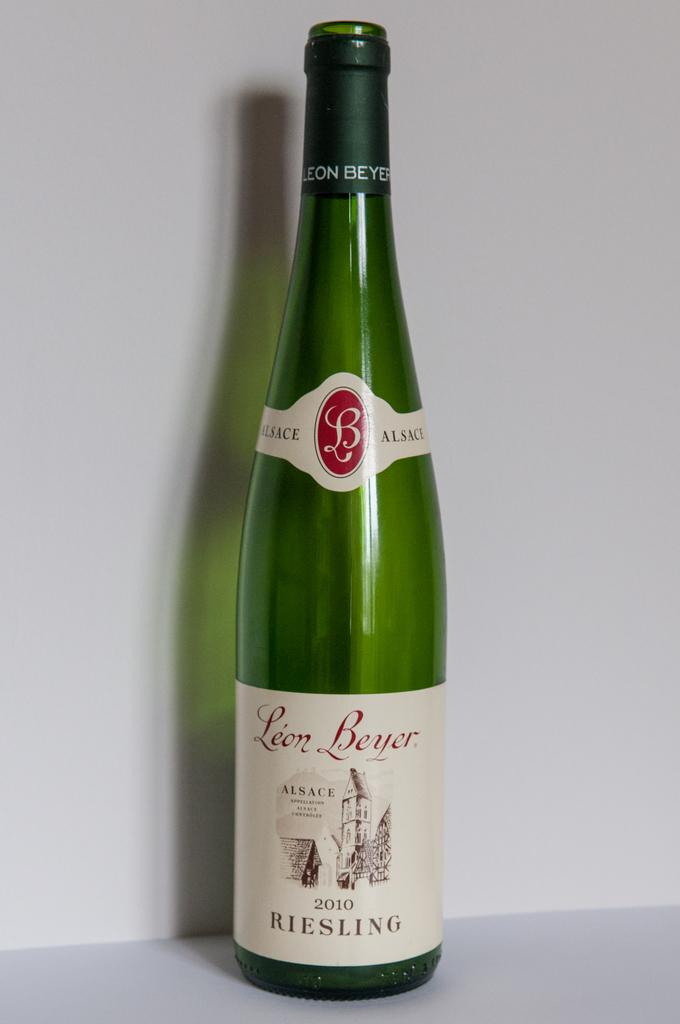<image>
Share a concise interpretation of the image provided. A bottle of Riesling wine has a year of 2010. 